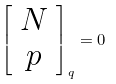<formula> <loc_0><loc_0><loc_500><loc_500>\left [ \begin{array} { c } N \\ p \end{array} \right ] _ { q } = 0</formula> 